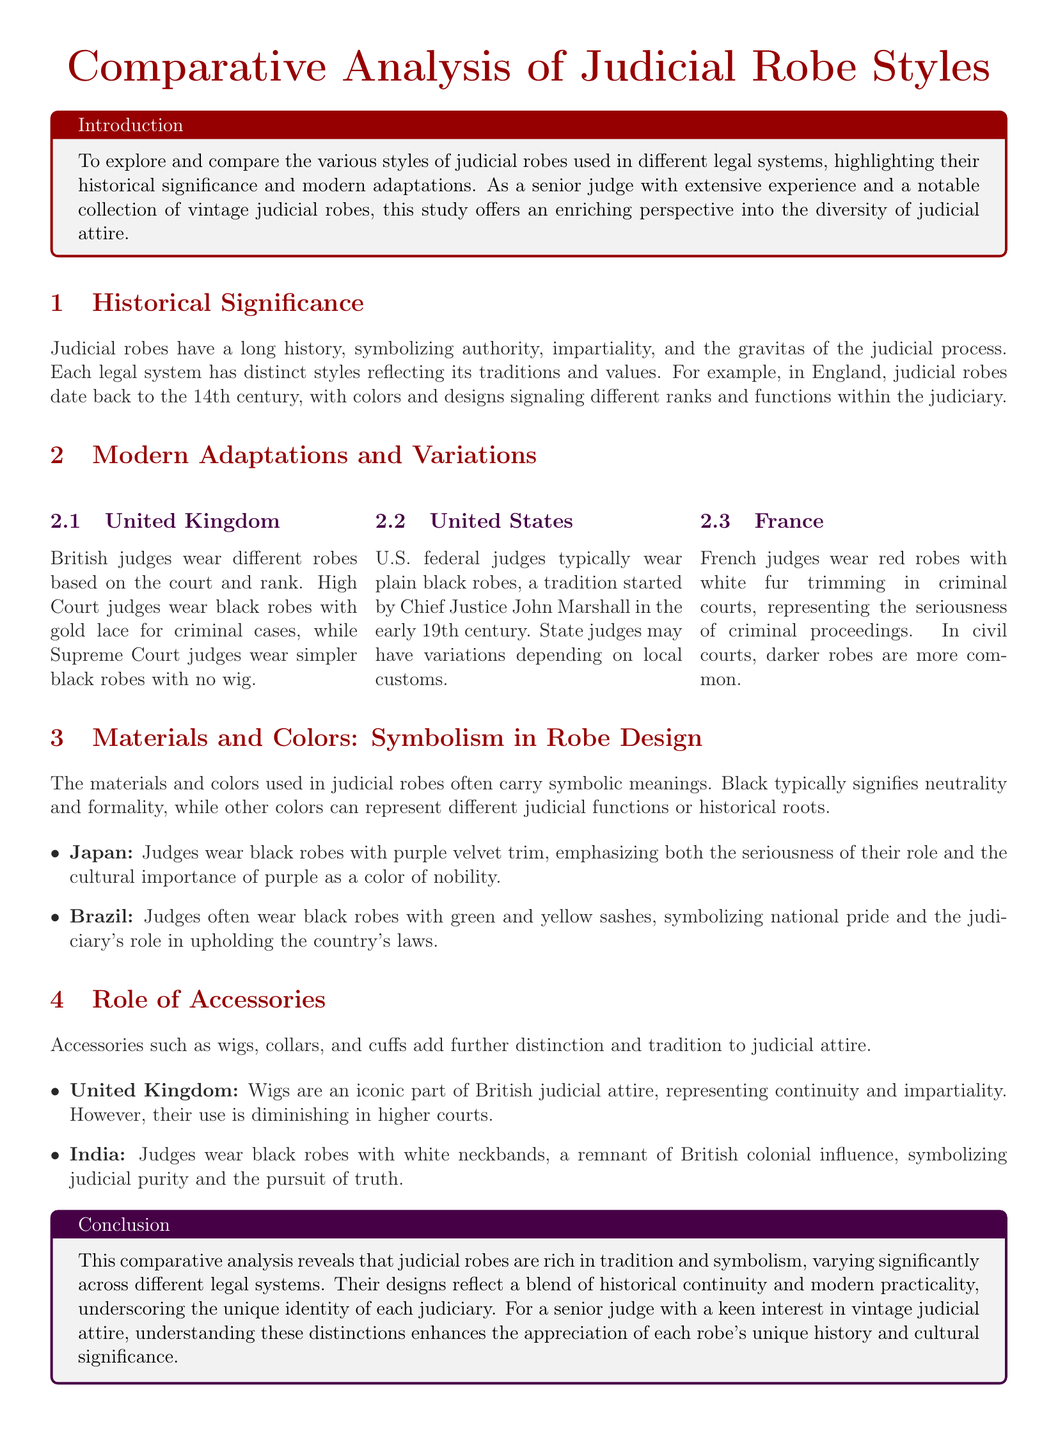What is the historical significance of judicial robes? Judicial robes symbolize authority, impartiality, and the gravitas of the judicial process.
Answer: Authority What color do British High Court judges wear for criminal cases? High Court judges wear black robes with gold lace for criminal cases.
Answer: Black with gold lace What is a common accessory in British judicial attire? Wigs are an iconic part of British judicial attire.
Answer: Wigs Which color represents neutrality and formality in judicial robes? Black typically signifies neutrality and formality in judicial robes.
Answer: Black What distinctive color is worn by French judges in criminal courts? French judges wear red robes with white fur trimming in criminal courts.
Answer: Red What does the green and yellow sash symbolize for Brazilian judges? The sashes symbolize national pride and the judiciary's role in upholding the country's laws.
Answer: National pride What is the robe color used by Japanese judges? Japanese judges wear black robes with purple velvet trim.
Answer: Black with purple trim How has the use of wigs in British courts changed? Their use is diminishing in higher courts.
Answer: Diminishing What colonial influence is seen in Indian judicial robes? Judges wear black robes with white neckbands, a remnant of British colonial influence.
Answer: British colonial influence 